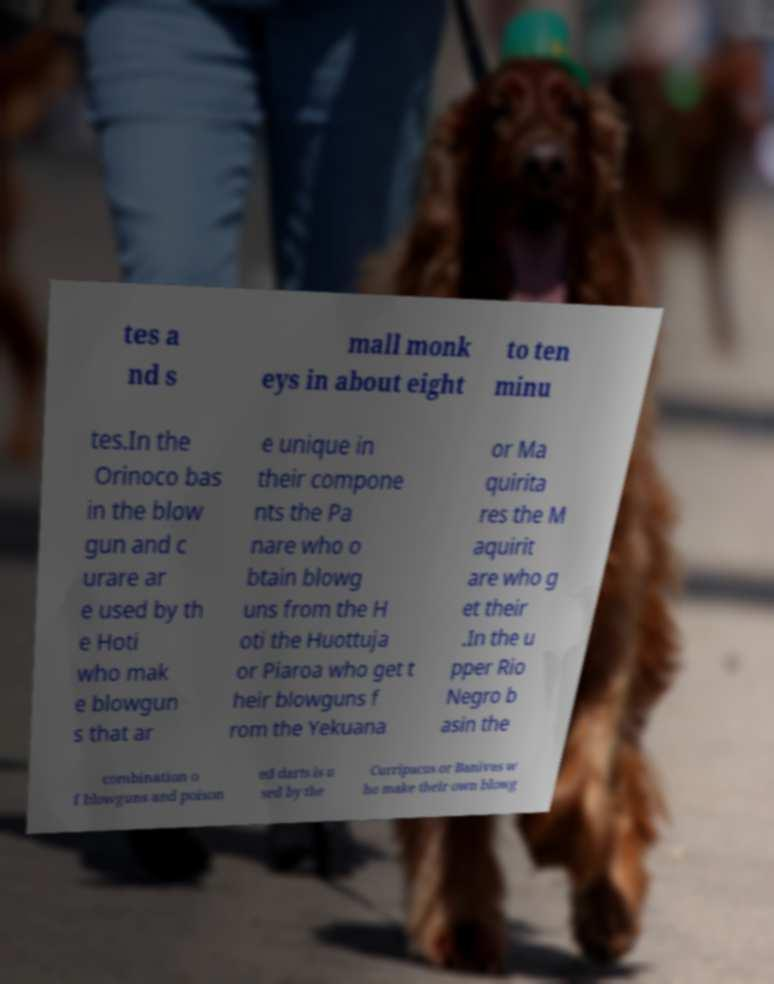What messages or text are displayed in this image? I need them in a readable, typed format. tes a nd s mall monk eys in about eight to ten minu tes.In the Orinoco bas in the blow gun and c urare ar e used by th e Hoti who mak e blowgun s that ar e unique in their compone nts the Pa nare who o btain blowg uns from the H oti the Huottuja or Piaroa who get t heir blowguns f rom the Yekuana or Ma quirita res the M aquirit are who g et their .In the u pper Rio Negro b asin the combination o f blowguns and poison ed darts is u sed by the Curripacos or Banivas w ho make their own blowg 